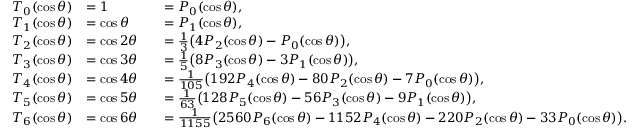<formula> <loc_0><loc_0><loc_500><loc_500>{ \begin{array} { r l r l } { T _ { 0 } ( \cos \theta ) } & { = 1 } & & { = P _ { 0 } ( \cos \theta ) , } \\ { T _ { 1 } ( \cos \theta ) } & { = \cos \theta } & & { = P _ { 1 } ( \cos \theta ) , } \\ { T _ { 2 } ( \cos \theta ) } & { = \cos 2 \theta } & & { = { \frac { 1 } { 3 } } { \left ( } 4 P _ { 2 } ( \cos \theta ) - P _ { 0 } ( \cos \theta ) { \right ) } , } \\ { T _ { 3 } ( \cos \theta ) } & { = \cos 3 \theta } & & { = { \frac { 1 } { 5 } } { \left ( } 8 P _ { 3 } ( \cos \theta ) - 3 P _ { 1 } ( \cos \theta ) { \right ) } , } \\ { T _ { 4 } ( \cos \theta ) } & { = \cos 4 \theta } & & { = { \frac { 1 } { 1 0 5 } } { \left ( } 1 9 2 P _ { 4 } ( \cos \theta ) - 8 0 P _ { 2 } ( \cos \theta ) - 7 P _ { 0 } ( \cos \theta ) { \right ) } , } \\ { T _ { 5 } ( \cos \theta ) } & { = \cos 5 \theta } & & { = { \frac { 1 } { 6 3 } } { \left ( } 1 2 8 P _ { 5 } ( \cos \theta ) - 5 6 P _ { 3 } ( \cos \theta ) - 9 P _ { 1 } ( \cos \theta ) { \right ) } , } \\ { T _ { 6 } ( \cos \theta ) } & { = \cos 6 \theta } & & { = { \frac { 1 } { 1 1 5 5 } } { \left ( } 2 5 6 0 P _ { 6 } ( \cos \theta ) - 1 1 5 2 P _ { 4 } ( \cos \theta ) - 2 2 0 P _ { 2 } ( \cos \theta ) - 3 3 P _ { 0 } ( \cos \theta ) { \right ) } . } \end{array} }</formula> 